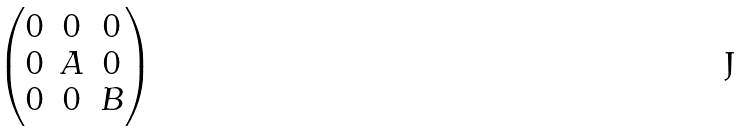Convert formula to latex. <formula><loc_0><loc_0><loc_500><loc_500>\begin{pmatrix} 0 & 0 & 0 \\ 0 & A & 0 \\ 0 & 0 & B \end{pmatrix}</formula> 